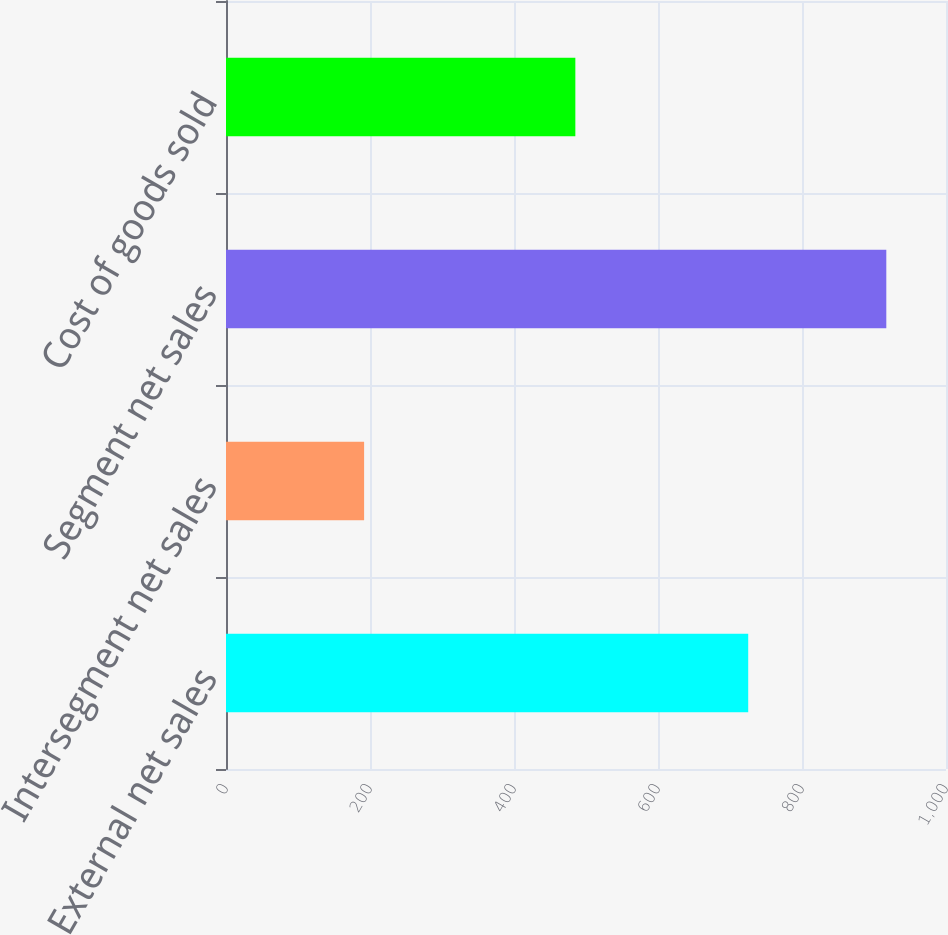Convert chart. <chart><loc_0><loc_0><loc_500><loc_500><bar_chart><fcel>External net sales<fcel>Intersegment net sales<fcel>Segment net sales<fcel>Cost of goods sold<nl><fcel>725.3<fcel>191.8<fcel>917.1<fcel>485.2<nl></chart> 